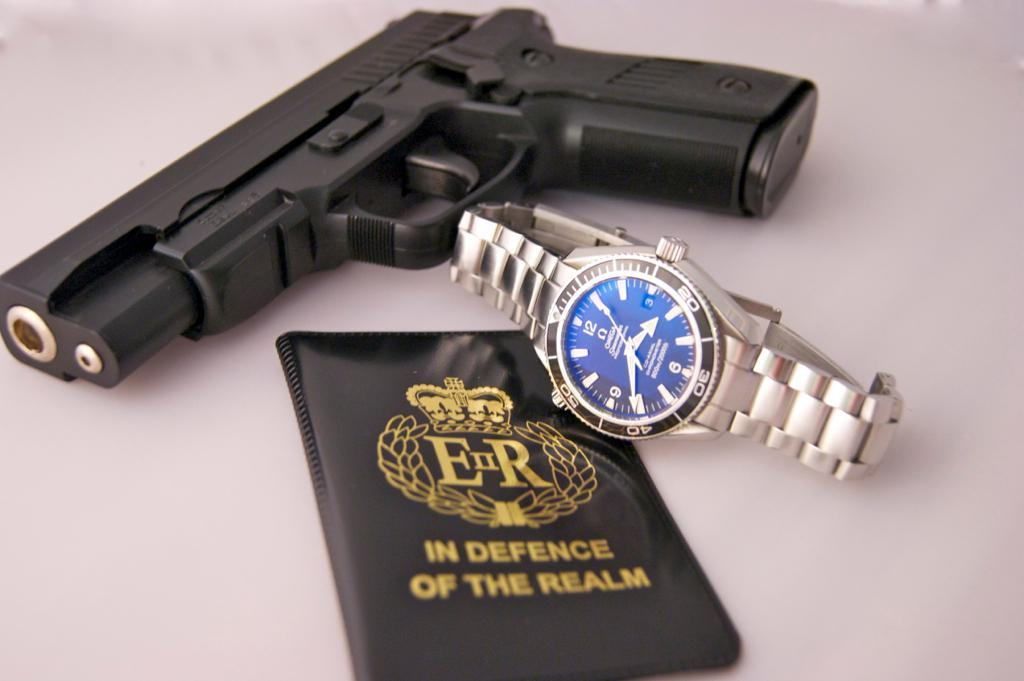What object with a handle is present on the table in the image? There is a black color gun on the table. What time-keeping device is on the table? There is a watch on the table. What type of identification document is on the table? There is a passport on the table. Can you see a goldfish swimming in the image? There is no goldfish present in the image. What type of tool is being used to adjust the nose in the image? There is no tool or nose present in the image. 